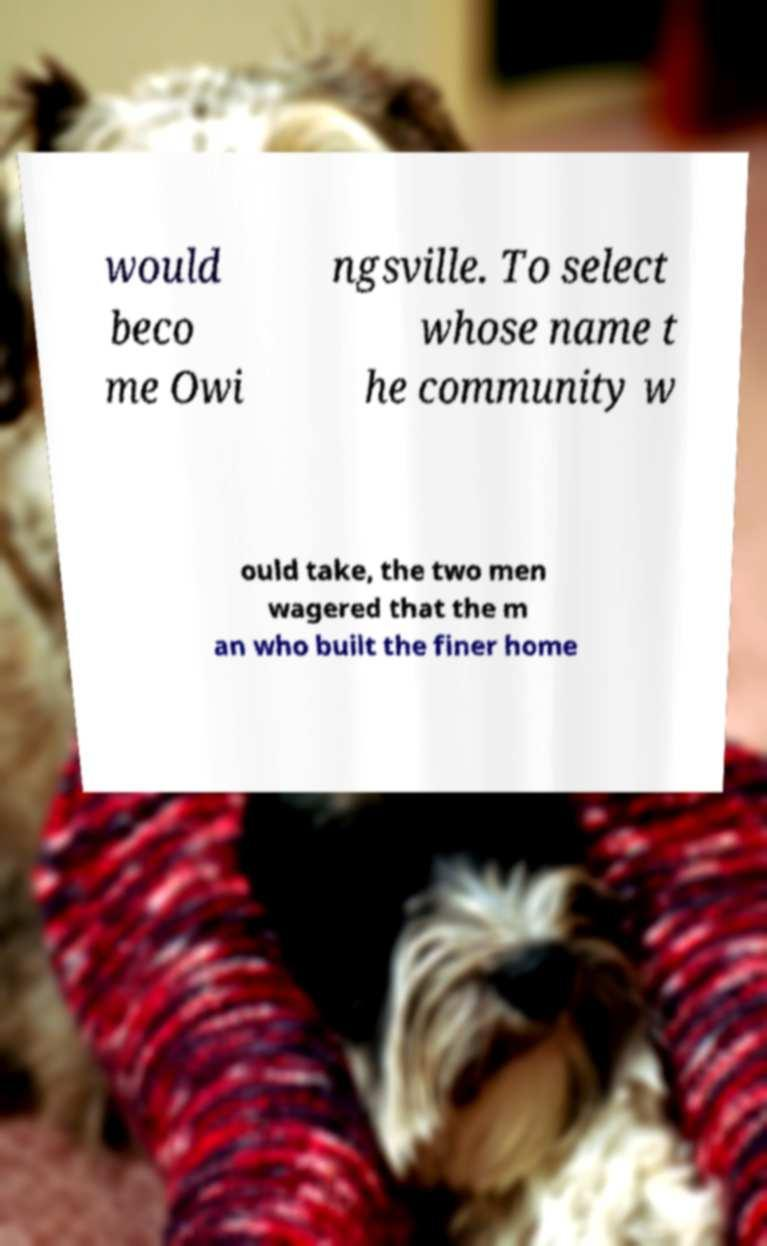Please identify and transcribe the text found in this image. would beco me Owi ngsville. To select whose name t he community w ould take, the two men wagered that the m an who built the finer home 